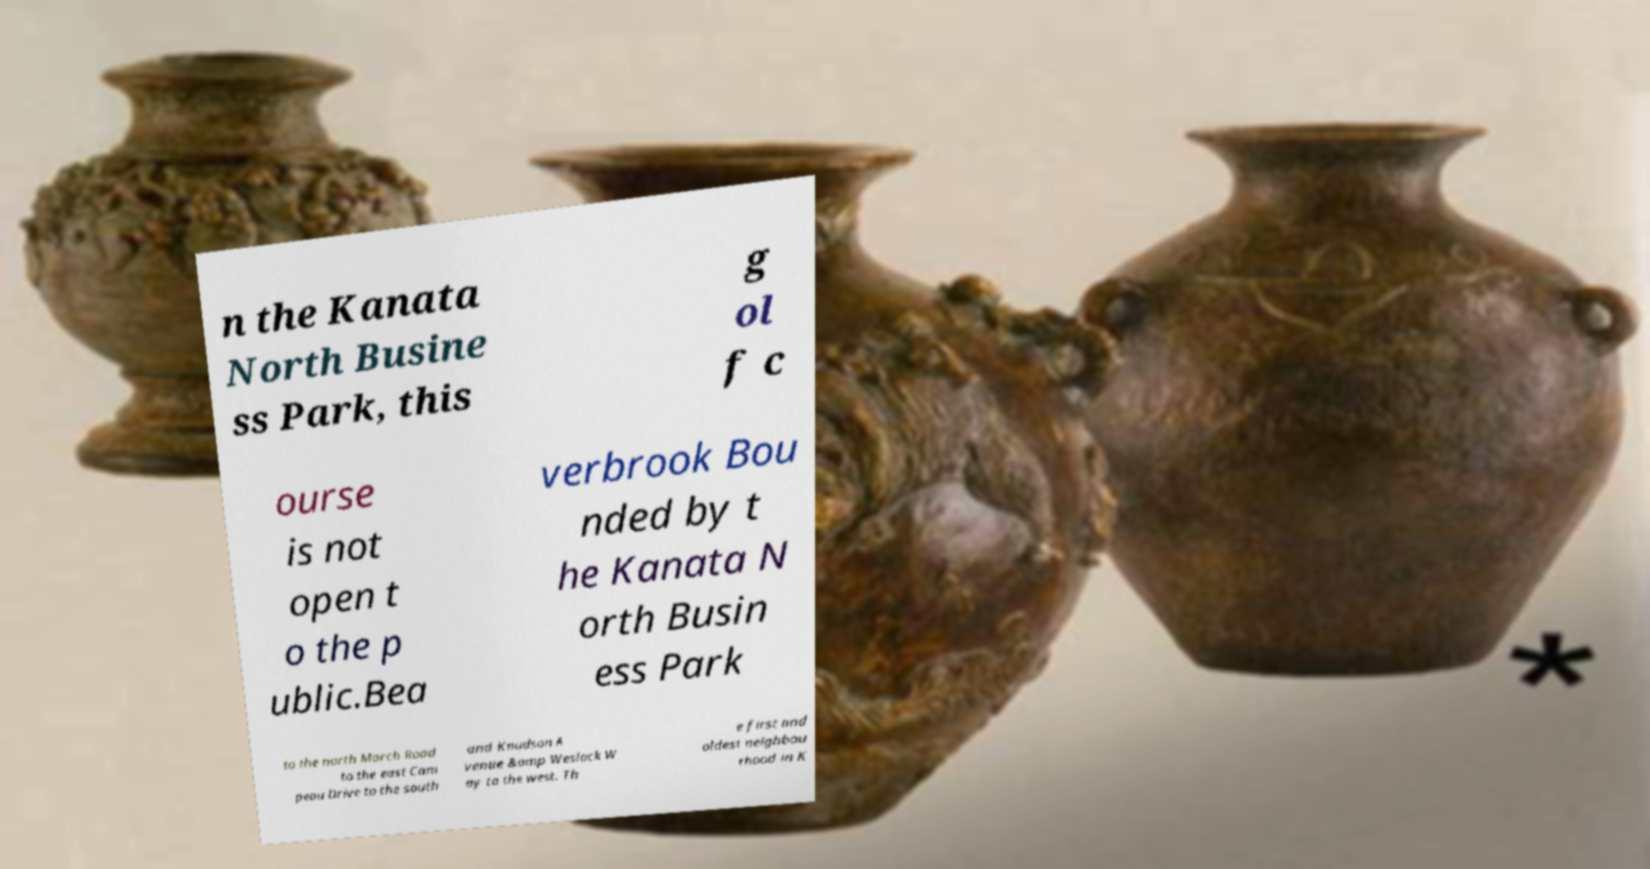Could you extract and type out the text from this image? n the Kanata North Busine ss Park, this g ol f c ourse is not open t o the p ublic.Bea verbrook Bou nded by t he Kanata N orth Busin ess Park to the north March Road to the east Cam peau Drive to the south and Knudson A venue &amp Weslock W ay to the west. Th e first and oldest neighbou rhood in K 